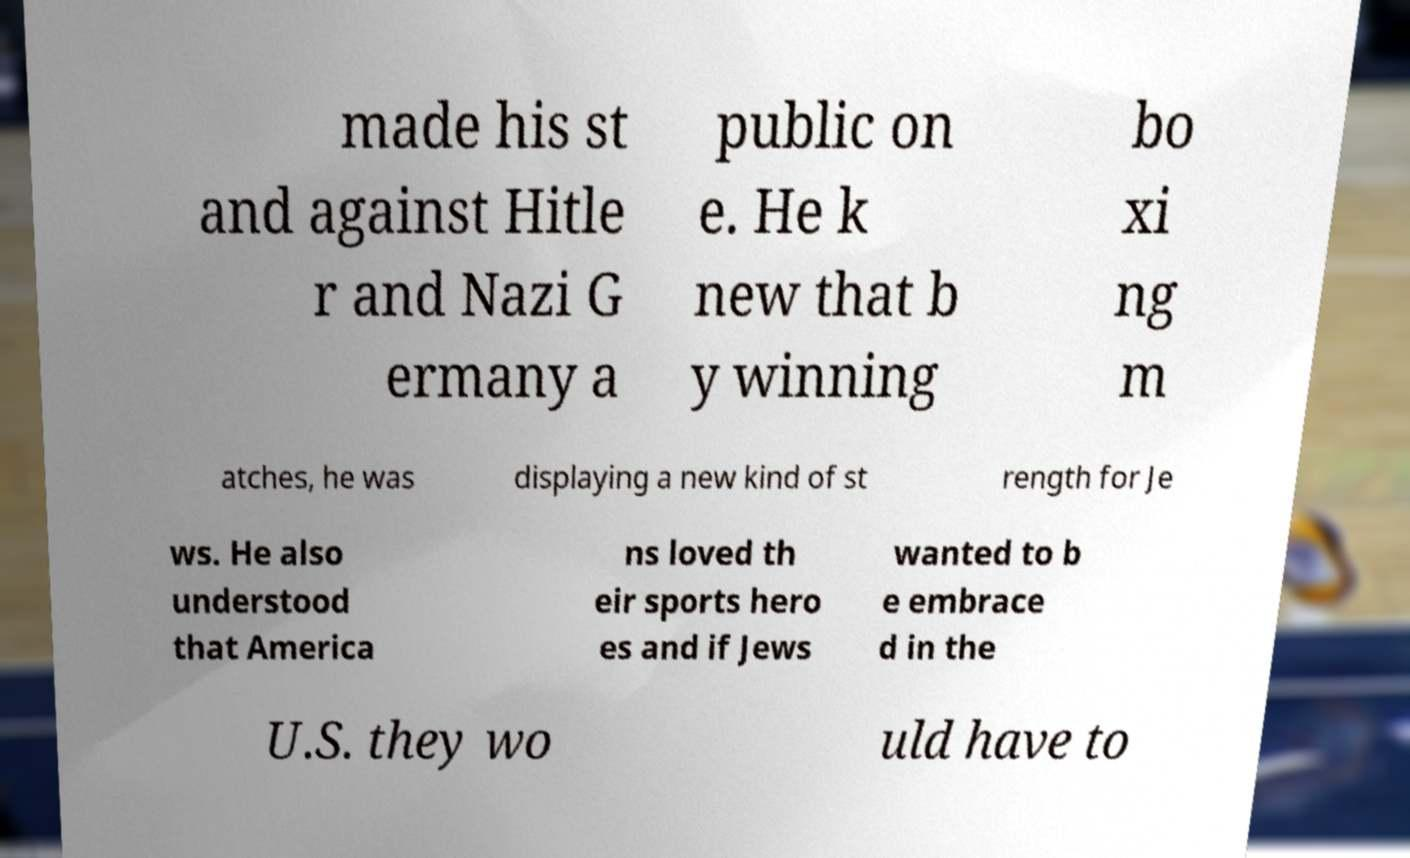Can you read and provide the text displayed in the image?This photo seems to have some interesting text. Can you extract and type it out for me? made his st and against Hitle r and Nazi G ermany a public on e. He k new that b y winning bo xi ng m atches, he was displaying a new kind of st rength for Je ws. He also understood that America ns loved th eir sports hero es and if Jews wanted to b e embrace d in the U.S. they wo uld have to 